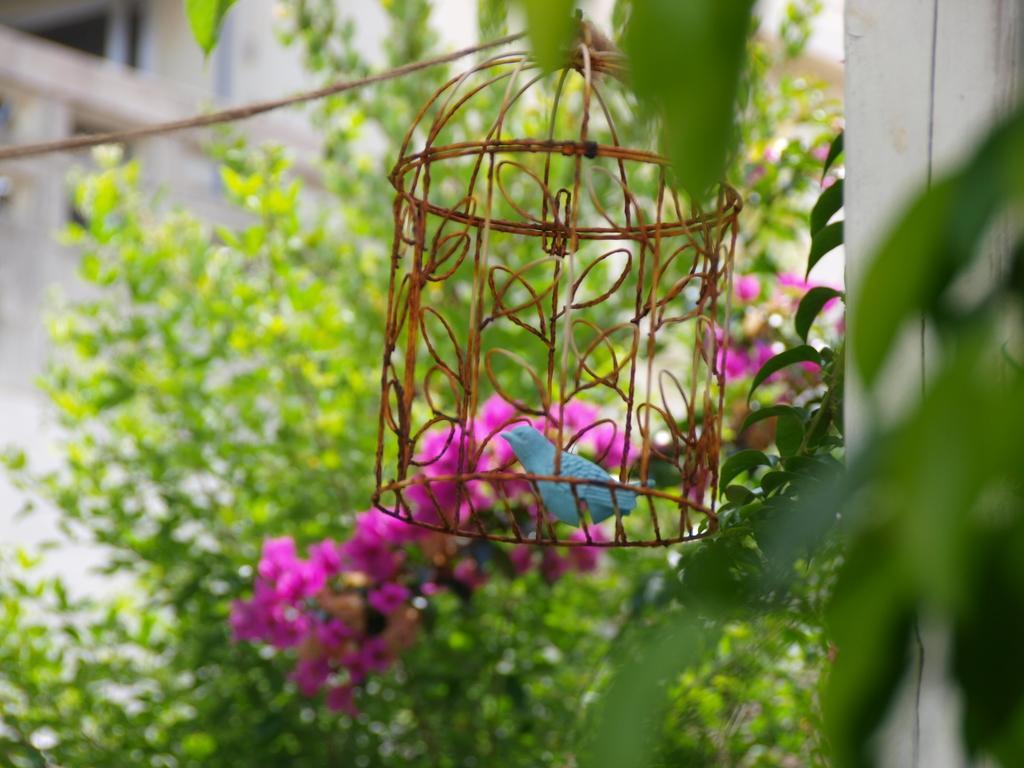Describe this image in one or two sentences. In this image we can see a bird in a cage, flowers, rope, and leaves. In the background we can see wall. 